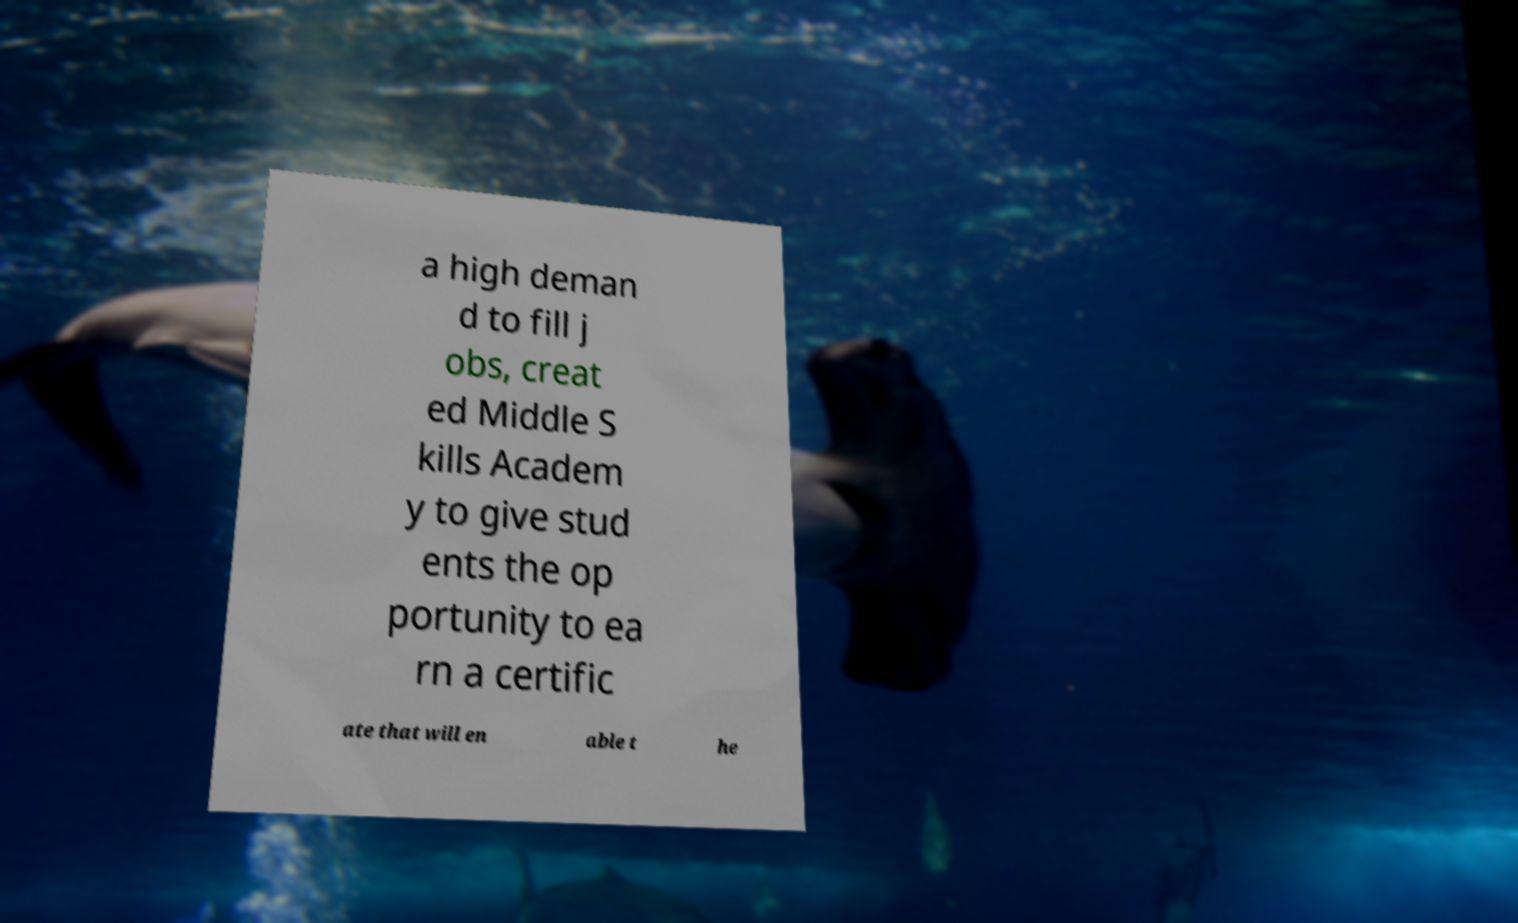Please read and relay the text visible in this image. What does it say? a high deman d to fill j obs, creat ed Middle S kills Academ y to give stud ents the op portunity to ea rn a certific ate that will en able t he 